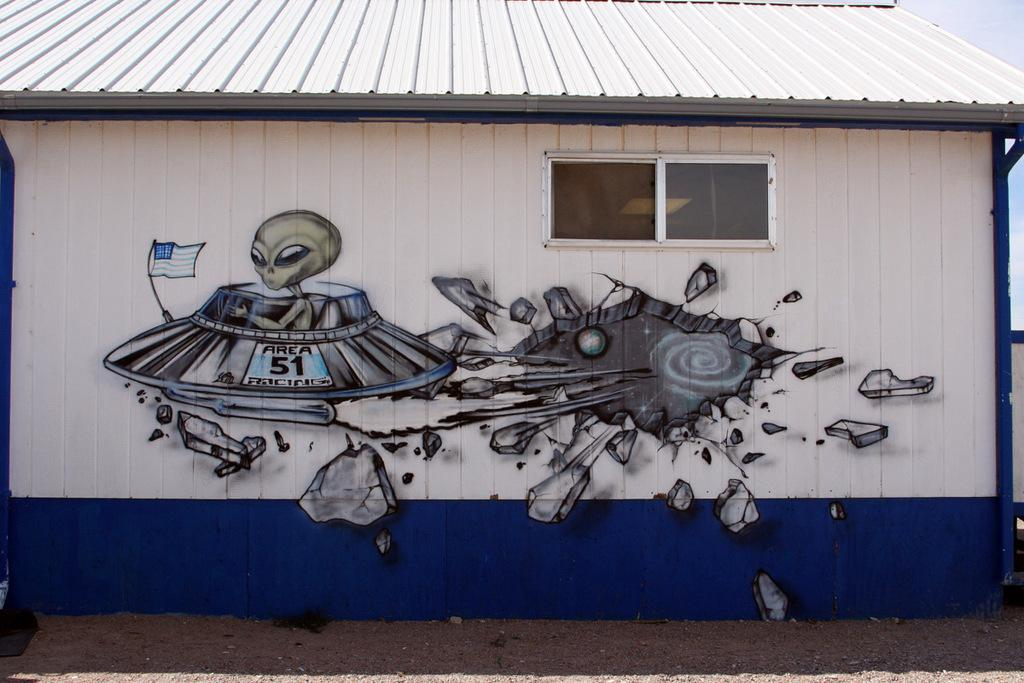What is on the wall of the house in the image? There is graffiti on the wall of a house in the image. What can be seen in the background of the image? The sky is visible in the background of the image. What type of card can be seen being held by the beast in the image? There is no beast or card present in the image; it only features graffiti on a wall and the sky in the background. 